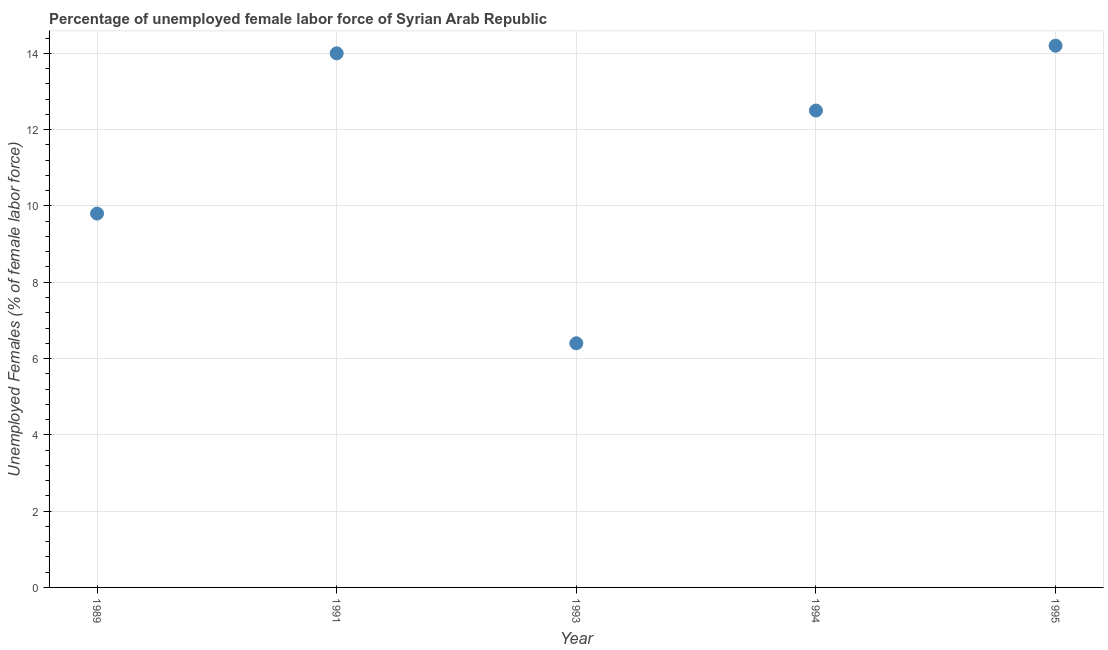What is the total unemployed female labour force in 1995?
Provide a short and direct response. 14.2. Across all years, what is the maximum total unemployed female labour force?
Provide a short and direct response. 14.2. Across all years, what is the minimum total unemployed female labour force?
Ensure brevity in your answer.  6.4. In which year was the total unemployed female labour force maximum?
Keep it short and to the point. 1995. What is the sum of the total unemployed female labour force?
Offer a very short reply. 56.9. What is the difference between the total unemployed female labour force in 1989 and 1991?
Make the answer very short. -4.2. What is the average total unemployed female labour force per year?
Make the answer very short. 11.38. Do a majority of the years between 1995 and 1993 (inclusive) have total unemployed female labour force greater than 4.4 %?
Your response must be concise. No. What is the ratio of the total unemployed female labour force in 1989 to that in 1994?
Your answer should be very brief. 0.78. What is the difference between the highest and the second highest total unemployed female labour force?
Keep it short and to the point. 0.2. What is the difference between the highest and the lowest total unemployed female labour force?
Give a very brief answer. 7.8. In how many years, is the total unemployed female labour force greater than the average total unemployed female labour force taken over all years?
Ensure brevity in your answer.  3. Does the total unemployed female labour force monotonically increase over the years?
Offer a terse response. No. How many dotlines are there?
Ensure brevity in your answer.  1. Does the graph contain grids?
Provide a succinct answer. Yes. What is the title of the graph?
Offer a terse response. Percentage of unemployed female labor force of Syrian Arab Republic. What is the label or title of the Y-axis?
Provide a short and direct response. Unemployed Females (% of female labor force). What is the Unemployed Females (% of female labor force) in 1989?
Your answer should be compact. 9.8. What is the Unemployed Females (% of female labor force) in 1991?
Offer a very short reply. 14. What is the Unemployed Females (% of female labor force) in 1993?
Offer a very short reply. 6.4. What is the Unemployed Females (% of female labor force) in 1994?
Offer a terse response. 12.5. What is the Unemployed Females (% of female labor force) in 1995?
Ensure brevity in your answer.  14.2. What is the difference between the Unemployed Females (% of female labor force) in 1989 and 1991?
Offer a terse response. -4.2. What is the difference between the Unemployed Females (% of female labor force) in 1989 and 1993?
Your answer should be compact. 3.4. What is the difference between the Unemployed Females (% of female labor force) in 1993 and 1994?
Offer a terse response. -6.1. What is the difference between the Unemployed Females (% of female labor force) in 1994 and 1995?
Your answer should be very brief. -1.7. What is the ratio of the Unemployed Females (% of female labor force) in 1989 to that in 1993?
Offer a very short reply. 1.53. What is the ratio of the Unemployed Females (% of female labor force) in 1989 to that in 1994?
Give a very brief answer. 0.78. What is the ratio of the Unemployed Females (% of female labor force) in 1989 to that in 1995?
Ensure brevity in your answer.  0.69. What is the ratio of the Unemployed Females (% of female labor force) in 1991 to that in 1993?
Make the answer very short. 2.19. What is the ratio of the Unemployed Females (% of female labor force) in 1991 to that in 1994?
Offer a terse response. 1.12. What is the ratio of the Unemployed Females (% of female labor force) in 1991 to that in 1995?
Your response must be concise. 0.99. What is the ratio of the Unemployed Females (% of female labor force) in 1993 to that in 1994?
Give a very brief answer. 0.51. What is the ratio of the Unemployed Females (% of female labor force) in 1993 to that in 1995?
Your answer should be compact. 0.45. What is the ratio of the Unemployed Females (% of female labor force) in 1994 to that in 1995?
Provide a succinct answer. 0.88. 